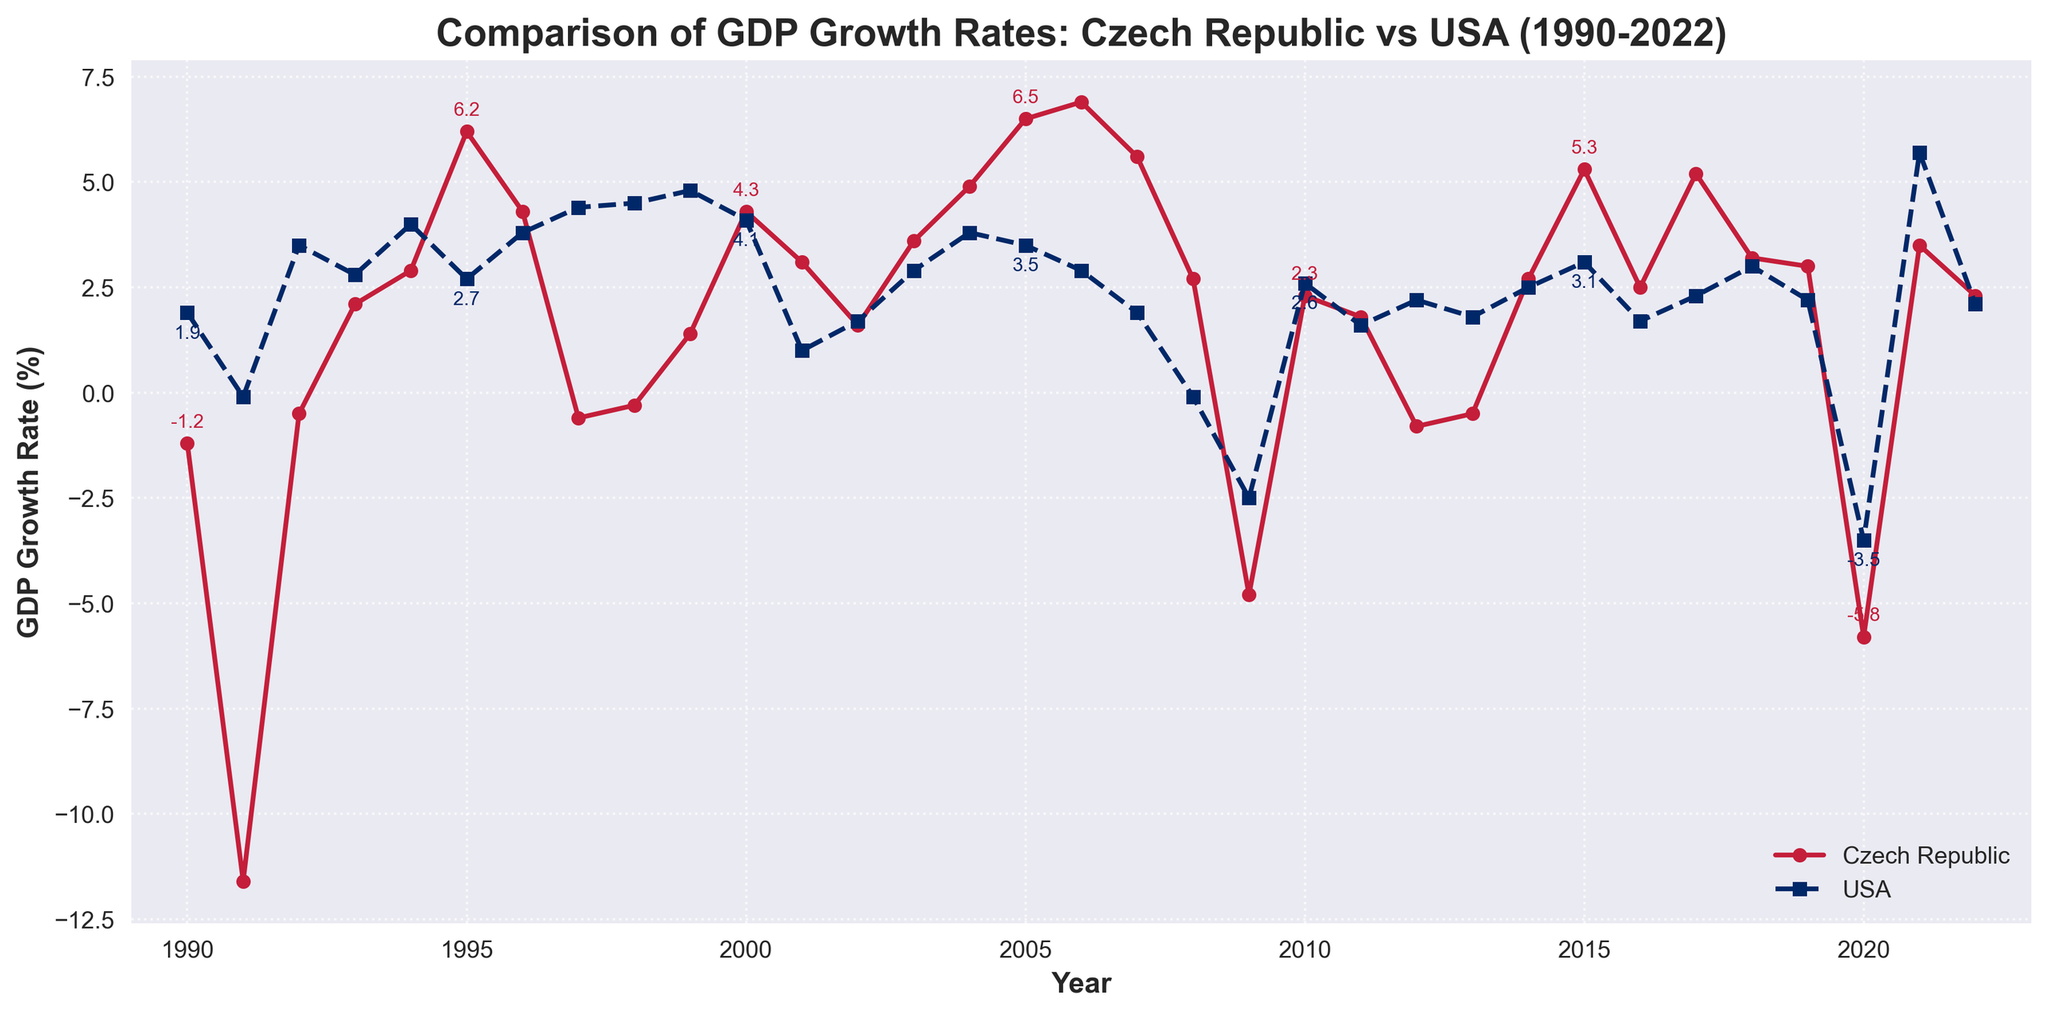What was the GDP growth rate of the Czech Republic and the USA in 1991? Look at the plot for the year 1991 and note the values for both countries. The Czech Republic's GDP growth rate is shown in red and the USA's in blue.
Answer: Czech Republic: -11.6%, USA: -0.1% In which year did the Czech Republic experience its highest GDP growth rate? Look at the peak points of the red line representing the Czech Republic's GDP growth rates. The highest peak looks to be in 2006.
Answer: 2006 How did the GDP growth rates of the Czech Republic and the USA compare in 2000? Find the values for the year 2000. The Czech Republic is represented by a red line and the USA by a blue dashed line. Compare the heights of the lines.
Answer: Czech Republic: 4.3%, USA: 4.1% Which country experienced a greater decrease in GDP growth rate from 2021 to 2022? Look at the difference between the GDP growth rates of each country from 2021 to 2022. Subtract the 2022 value from the 2021 value for both the Czech Republic and the USA.
Answer: Czech Republic: 1.2%, USA: 3.6%, Greater decrease: USA What pattern do you observe in the GDP growth rates of both countries during the 2008-2009 global financial crisis? Analyze the trend of both lines during the years 2008 and 2009. Both lines show a dramatic dip, indicating a significant drop in GDP growth rates during this period.
Answer: Both countries had large declines On which occasions did the Czech Republic show negative GDP growth rates? Examine the red line and identify years where the Czech Republic's GDP growth rate line is below the horizontal axis (0%).
Answer: 1990, 1991, 1992, 1997, 1998, 2009, 2012, 2013, 2020 Which year shows the highest GDP growth rate for the USA and what was the value? Look for the peak point in the dashed blue line representing the USA's GDP growth rates. The highest peak appears to be in 2021.
Answer: 2021, 5.7% Compare the average GDP growth rates of the Czech Republic and the USA from 2000 to 2010. Calculate the mean values for both countries over these years. For the Czech Republic: Sum(4.3+3.1+1.6+3.6+4.9+6.5+6.9+5.6+2.7-4.8+2.3) / 11 = 3.1. For the USA: Sum(4.1+1.0+1.7+2.9+3.8+3.5+2.9+1.9-0.1-2.5+2.6) / 11 = 1.8.
Answer: Czech Republic: 3.1%, USA: 1.8% Which country had a more stable GDP growth rate over the entire period, and how can you tell? Stability refers to less fluctuation. By looking at the plot, observe that the blue line (USA) shows fewer extreme changes compared to the red line (Czech Republic).
Answer: USA, less fluctuation 